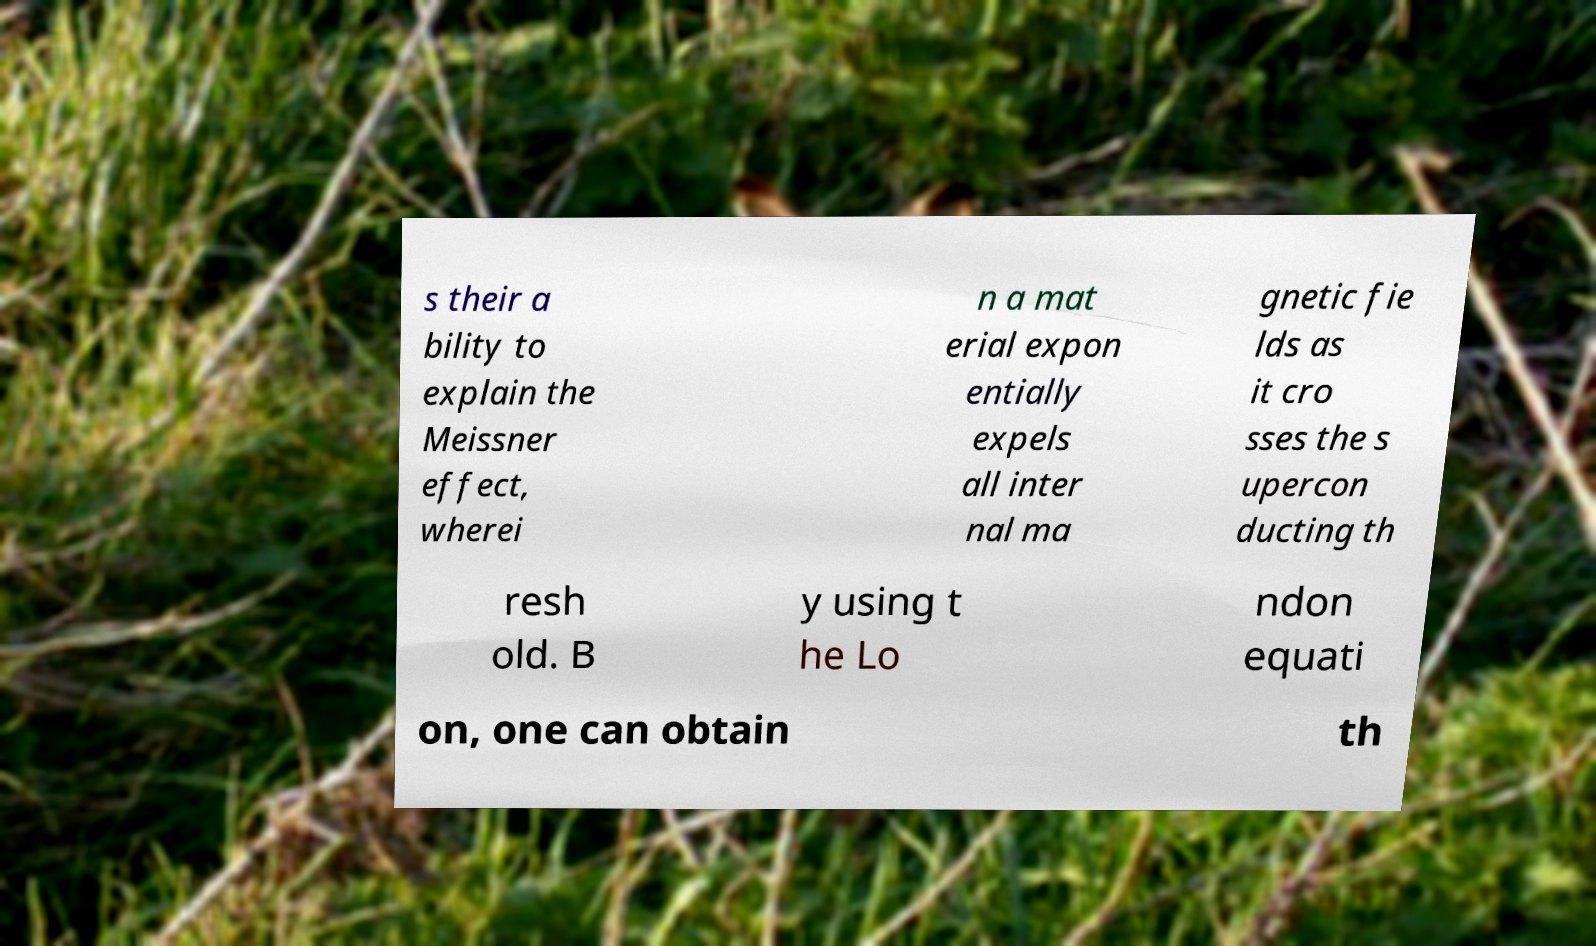Please read and relay the text visible in this image. What does it say? s their a bility to explain the Meissner effect, wherei n a mat erial expon entially expels all inter nal ma gnetic fie lds as it cro sses the s upercon ducting th resh old. B y using t he Lo ndon equati on, one can obtain th 